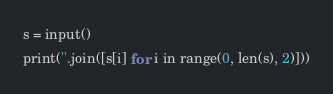<code> <loc_0><loc_0><loc_500><loc_500><_Python_>s = input()
print(''.join([s[i] for i in range(0, len(s), 2)]))</code> 